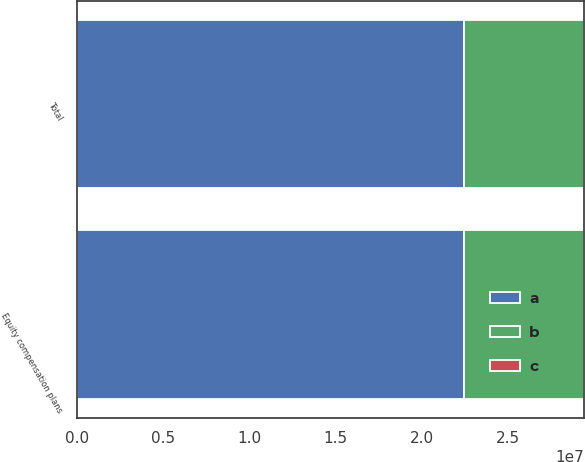Convert chart to OTSL. <chart><loc_0><loc_0><loc_500><loc_500><stacked_bar_chart><ecel><fcel>Equity compensation plans<fcel>Total<nl><fcel>b<fcel>6.9855e+06<fcel>6.9855e+06<nl><fcel>c<fcel>15.8<fcel>15.8<nl><fcel>a<fcel>2.24261e+07<fcel>2.24261e+07<nl></chart> 